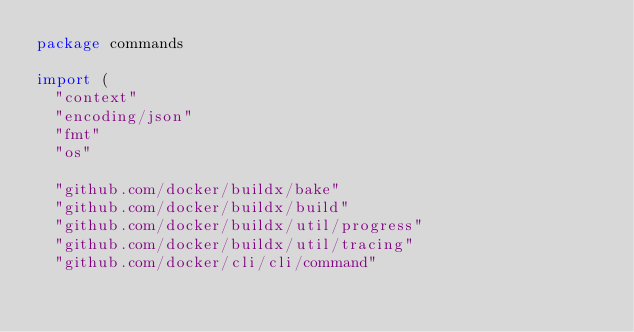Convert code to text. <code><loc_0><loc_0><loc_500><loc_500><_Go_>package commands

import (
	"context"
	"encoding/json"
	"fmt"
	"os"

	"github.com/docker/buildx/bake"
	"github.com/docker/buildx/build"
	"github.com/docker/buildx/util/progress"
	"github.com/docker/buildx/util/tracing"
	"github.com/docker/cli/cli/command"</code> 